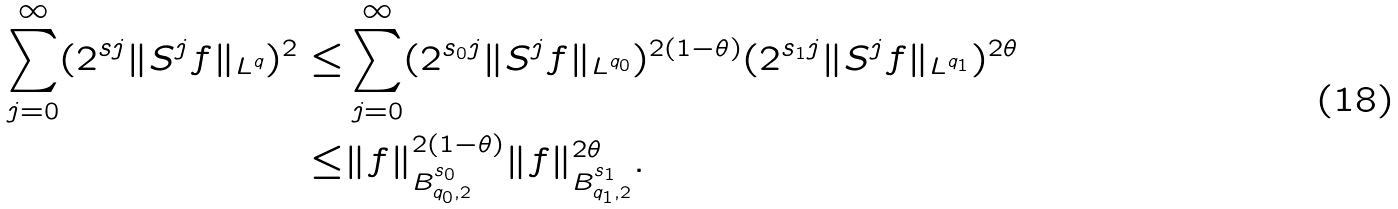<formula> <loc_0><loc_0><loc_500><loc_500>\sum _ { j = 0 } ^ { \infty } ( 2 ^ { s j } \| S ^ { j } f \| _ { L ^ { q } } ) ^ { 2 } \leq & \sum _ { j = 0 } ^ { \infty } ( 2 ^ { s _ { 0 } j } \| S ^ { j } f \| _ { L ^ { q _ { 0 } } } ) ^ { 2 ( 1 - \theta ) } ( 2 ^ { s _ { 1 } j } \| S ^ { j } f \| _ { L ^ { q _ { 1 } } } ) ^ { 2 \theta } \\ \leq & \| f \| _ { B ^ { s _ { 0 } } _ { q _ { 0 } , 2 } } ^ { 2 ( 1 - \theta ) } \| f \| _ { B ^ { s _ { 1 } } _ { q _ { 1 } , 2 } } ^ { 2 \theta } .</formula> 